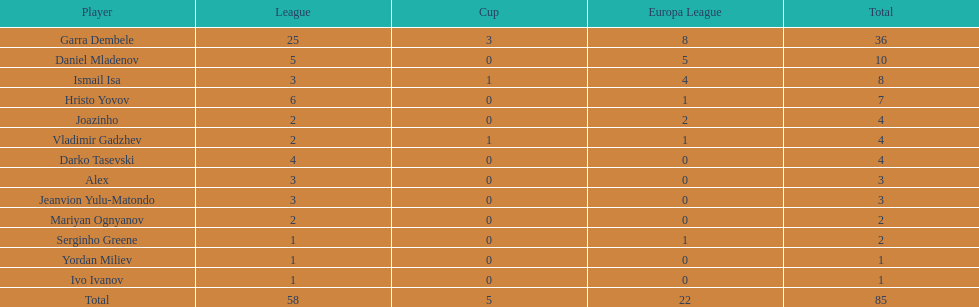Which players managed to score just a single goal? Serginho Greene, Yordan Miliev, Ivo Ivanov. 